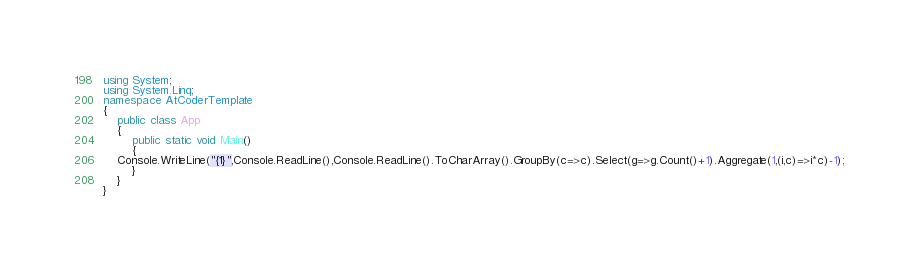Convert code to text. <code><loc_0><loc_0><loc_500><loc_500><_C#_>using System;
using System.Linq;
namespace AtCoderTemplate
{
    public class App
    {
        public static void Main()
        {
    Console.WriteLine("{1}",Console.ReadLine(),Console.ReadLine().ToCharArray().GroupBy(c=>c).Select(g=>g.Count()+1).Aggregate(1,(i,c)=>i*c)-1);
        }
    }
}</code> 